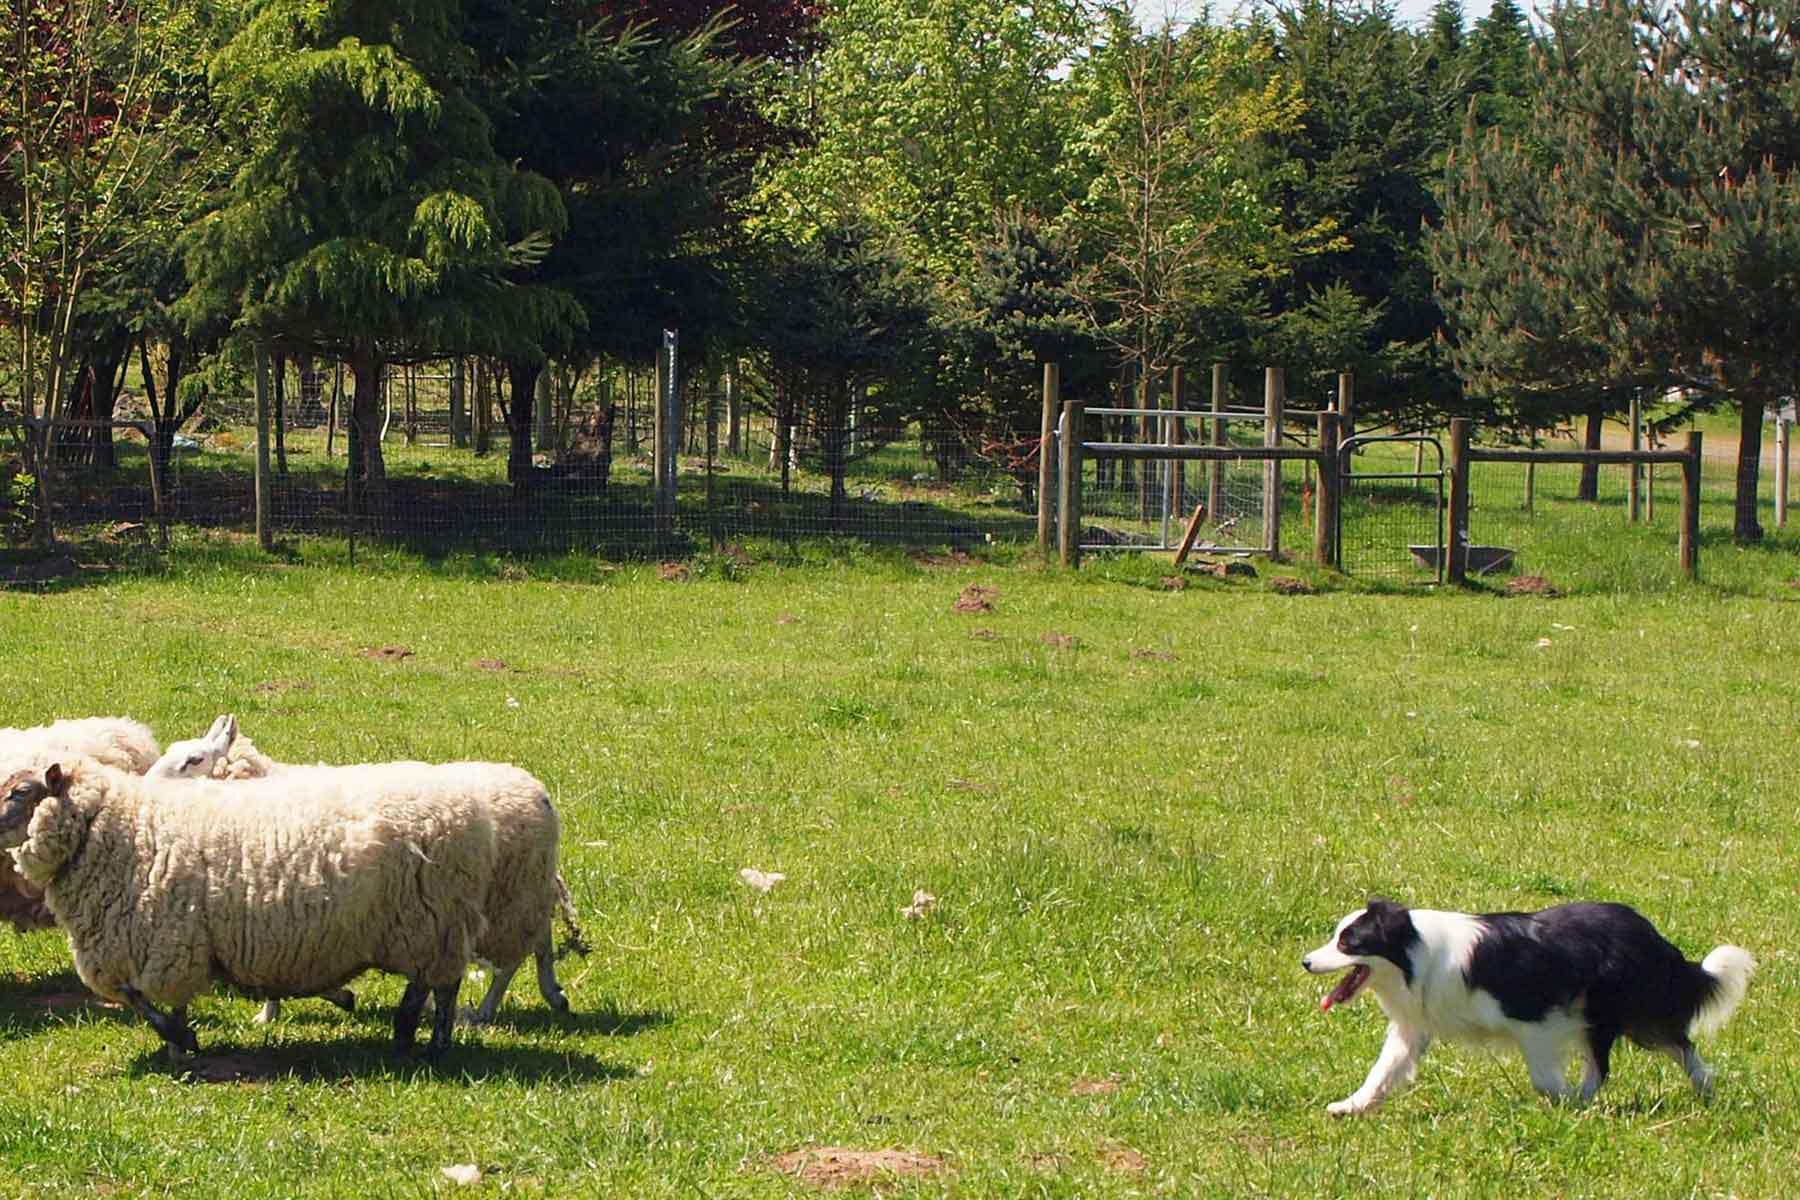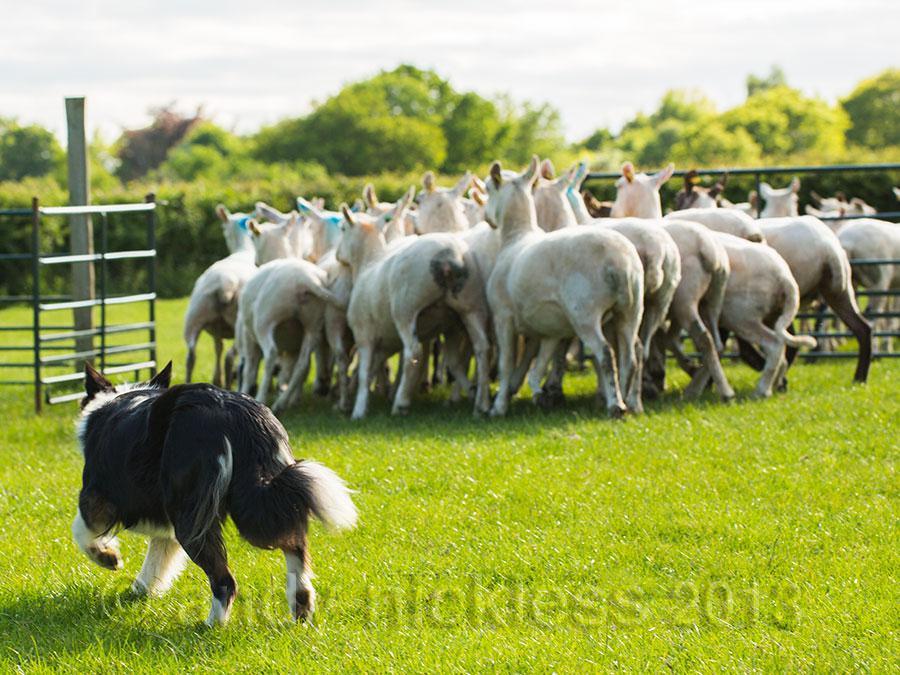The first image is the image on the left, the second image is the image on the right. Examine the images to the left and right. Is the description "The sheep are near an enclosure." accurate? Answer yes or no. Yes. The first image is the image on the left, the second image is the image on the right. Considering the images on both sides, is "One image shows a dog herding water fowl." valid? Answer yes or no. No. 